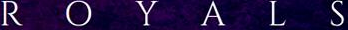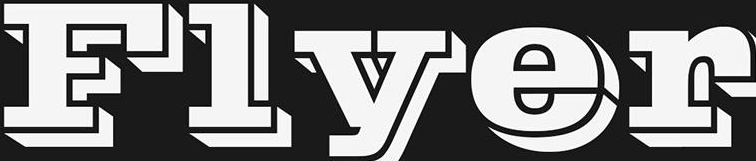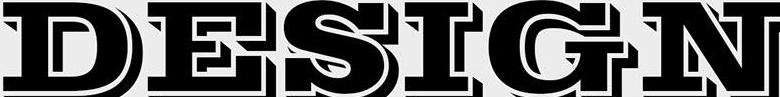What words can you see in these images in sequence, separated by a semicolon? ROYALS; Flyer; DESIGN 